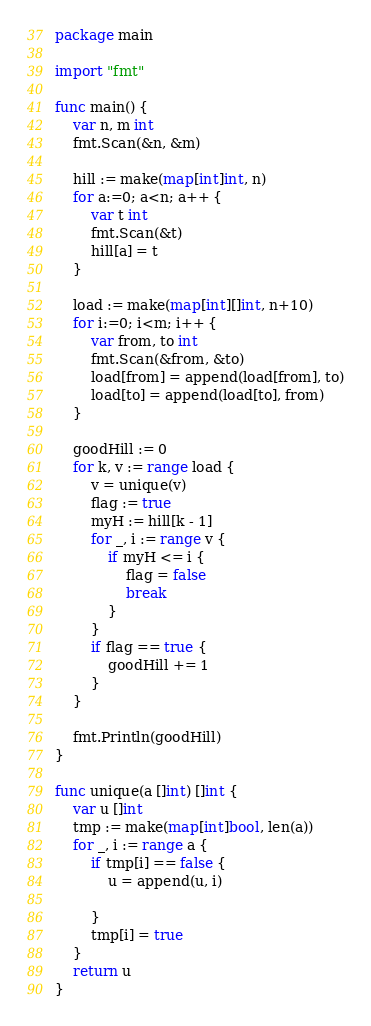<code> <loc_0><loc_0><loc_500><loc_500><_Go_>package main

import "fmt"

func main() {
	var n, m int
	fmt.Scan(&n, &m)

	hill := make(map[int]int, n)
	for a:=0; a<n; a++ {
		var t int
		fmt.Scan(&t)
		hill[a] = t
	}

	load := make(map[int][]int, n+10)
	for i:=0; i<m; i++ {
		var from, to int
		fmt.Scan(&from, &to)
		load[from] = append(load[from], to)
		load[to] = append(load[to], from)
	}

	goodHill := 0
	for k, v := range load {
		v = unique(v)
		flag := true
		myH := hill[k - 1]
		for _, i := range v {
			if myH <= i {
				flag = false
				break
			}
		}
		if flag == true {
			goodHill += 1
		}
	}

	fmt.Println(goodHill)
}

func unique(a []int) []int {
	var u []int
	tmp := make(map[int]bool, len(a))
	for _, i := range a {
		if tmp[i] == false {
			u = append(u, i)
			
		}
		tmp[i] = true
	}
	return u
}
</code> 